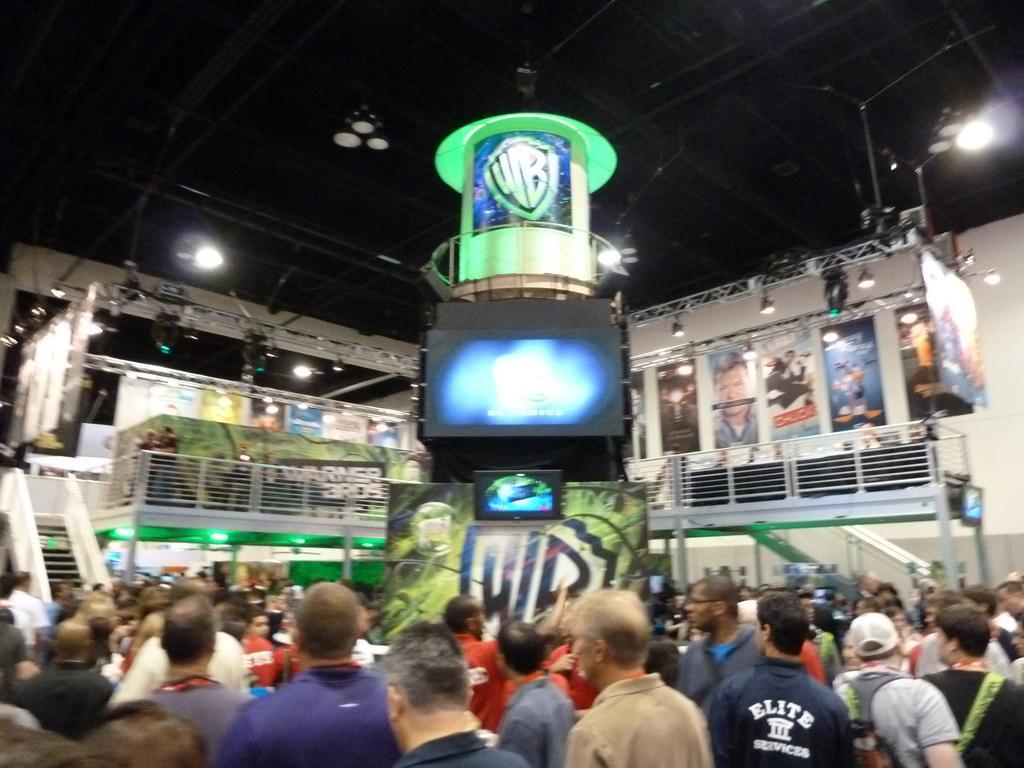Please provide a concise description of this image. In this image at the bottom there are group of people, and in the center of the image there are some boards, lights, railing, screen and some objects. And at the top of the image there is ceiling and some poles and lights. 